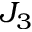Convert formula to latex. <formula><loc_0><loc_0><loc_500><loc_500>J _ { 3 }</formula> 